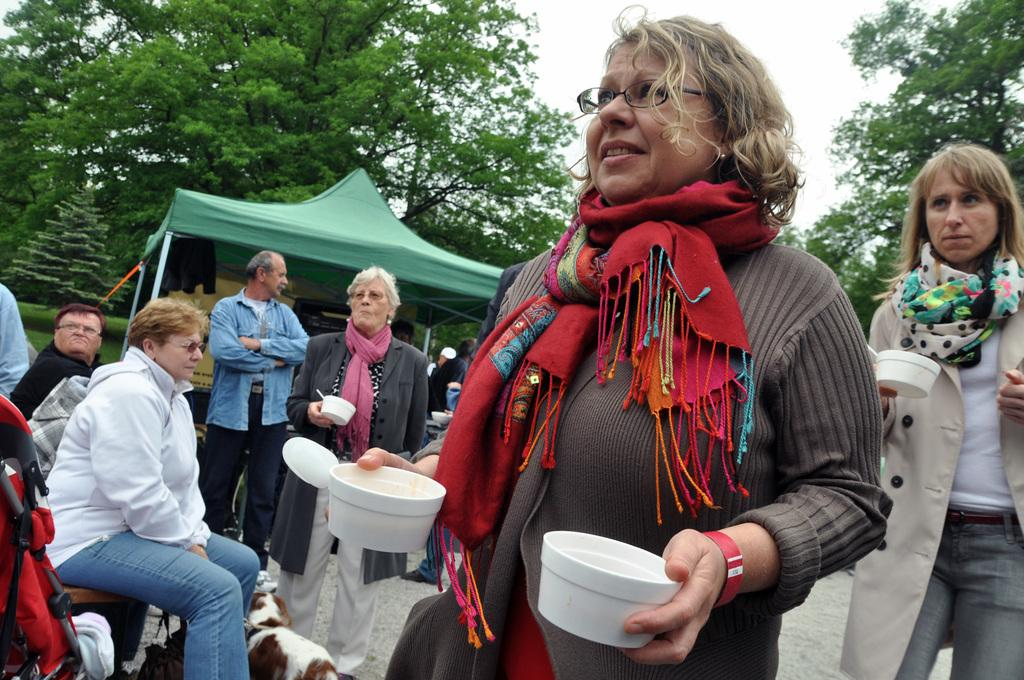What is the main subject of the image? There is a group of people in the image. Can you describe the appearance of one of the individuals in the group? A woman is wearing spectacles and a scarf. What is the woman holding in her hand? The woman is holding balls in her hand. What can be seen in the background of the image? There is a tent and a tree in the background of the image, as well as the sky. What type of coil is being used for the science experiment in the image? There is no science experiment or coil present in the image. How many apples are being held by the woman in the image? The woman is not holding any apples in the image; she is holding balls. 